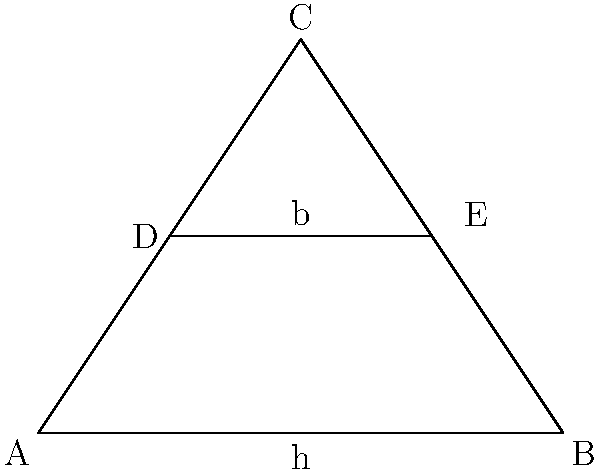In a developing country with limited flat land, you're designing a solar panel array for a rural community. The available area is triangular, as shown in the diagram. To maximize efficiency, you need to determine the optimal height for placing a horizontal row of solar panels. If the base of the triangle is 4 units and the height is 3 units, at what height should the horizontal row (represented by DE) be placed to maximize the area above and below it? Express your answer as a fraction of the triangle's height. To solve this problem, we'll follow these steps:

1) First, recall that the area of a triangle is given by $A = \frac{1}{2} \cdot base \cdot height$.

2) Let's denote the height at which we place the horizontal row as $h$ (from the base).

3) The total area of the triangle is $A_{total} = \frac{1}{2} \cdot 4 \cdot 3 = 6$ square units.

4) The area above the horizontal row is $A_{top} = \frac{1}{2} \cdot 4 \cdot (3-h)$.

5) The area below the horizontal row is $A_{bottom} = \frac{1}{2} \cdot 4 \cdot h$.

6) To maximize efficiency, we want these areas to be equal: $A_{top} = A_{bottom}$

7) This gives us the equation:
   $\frac{1}{2} \cdot 4 \cdot (3-h) = \frac{1}{2} \cdot 4 \cdot h$

8) Simplifying:
   $3-h = h$
   $3 = 2h$
   $h = \frac{3}{2}$

9) The total height of the triangle is 3 units, so the optimal height as a fraction of the triangle's height is:
   $\frac{h}{3} = \frac{3/2}{3} = \frac{1}{2}$

Therefore, the horizontal row should be placed at half the height of the triangle to maximize efficiency.
Answer: $\frac{1}{2}$ 